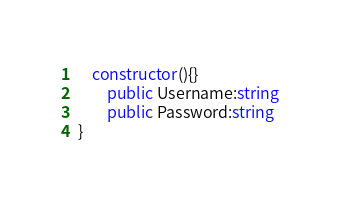<code> <loc_0><loc_0><loc_500><loc_500><_TypeScript_>    constructor(){}
        public Username:string
        public Password:string
}</code> 